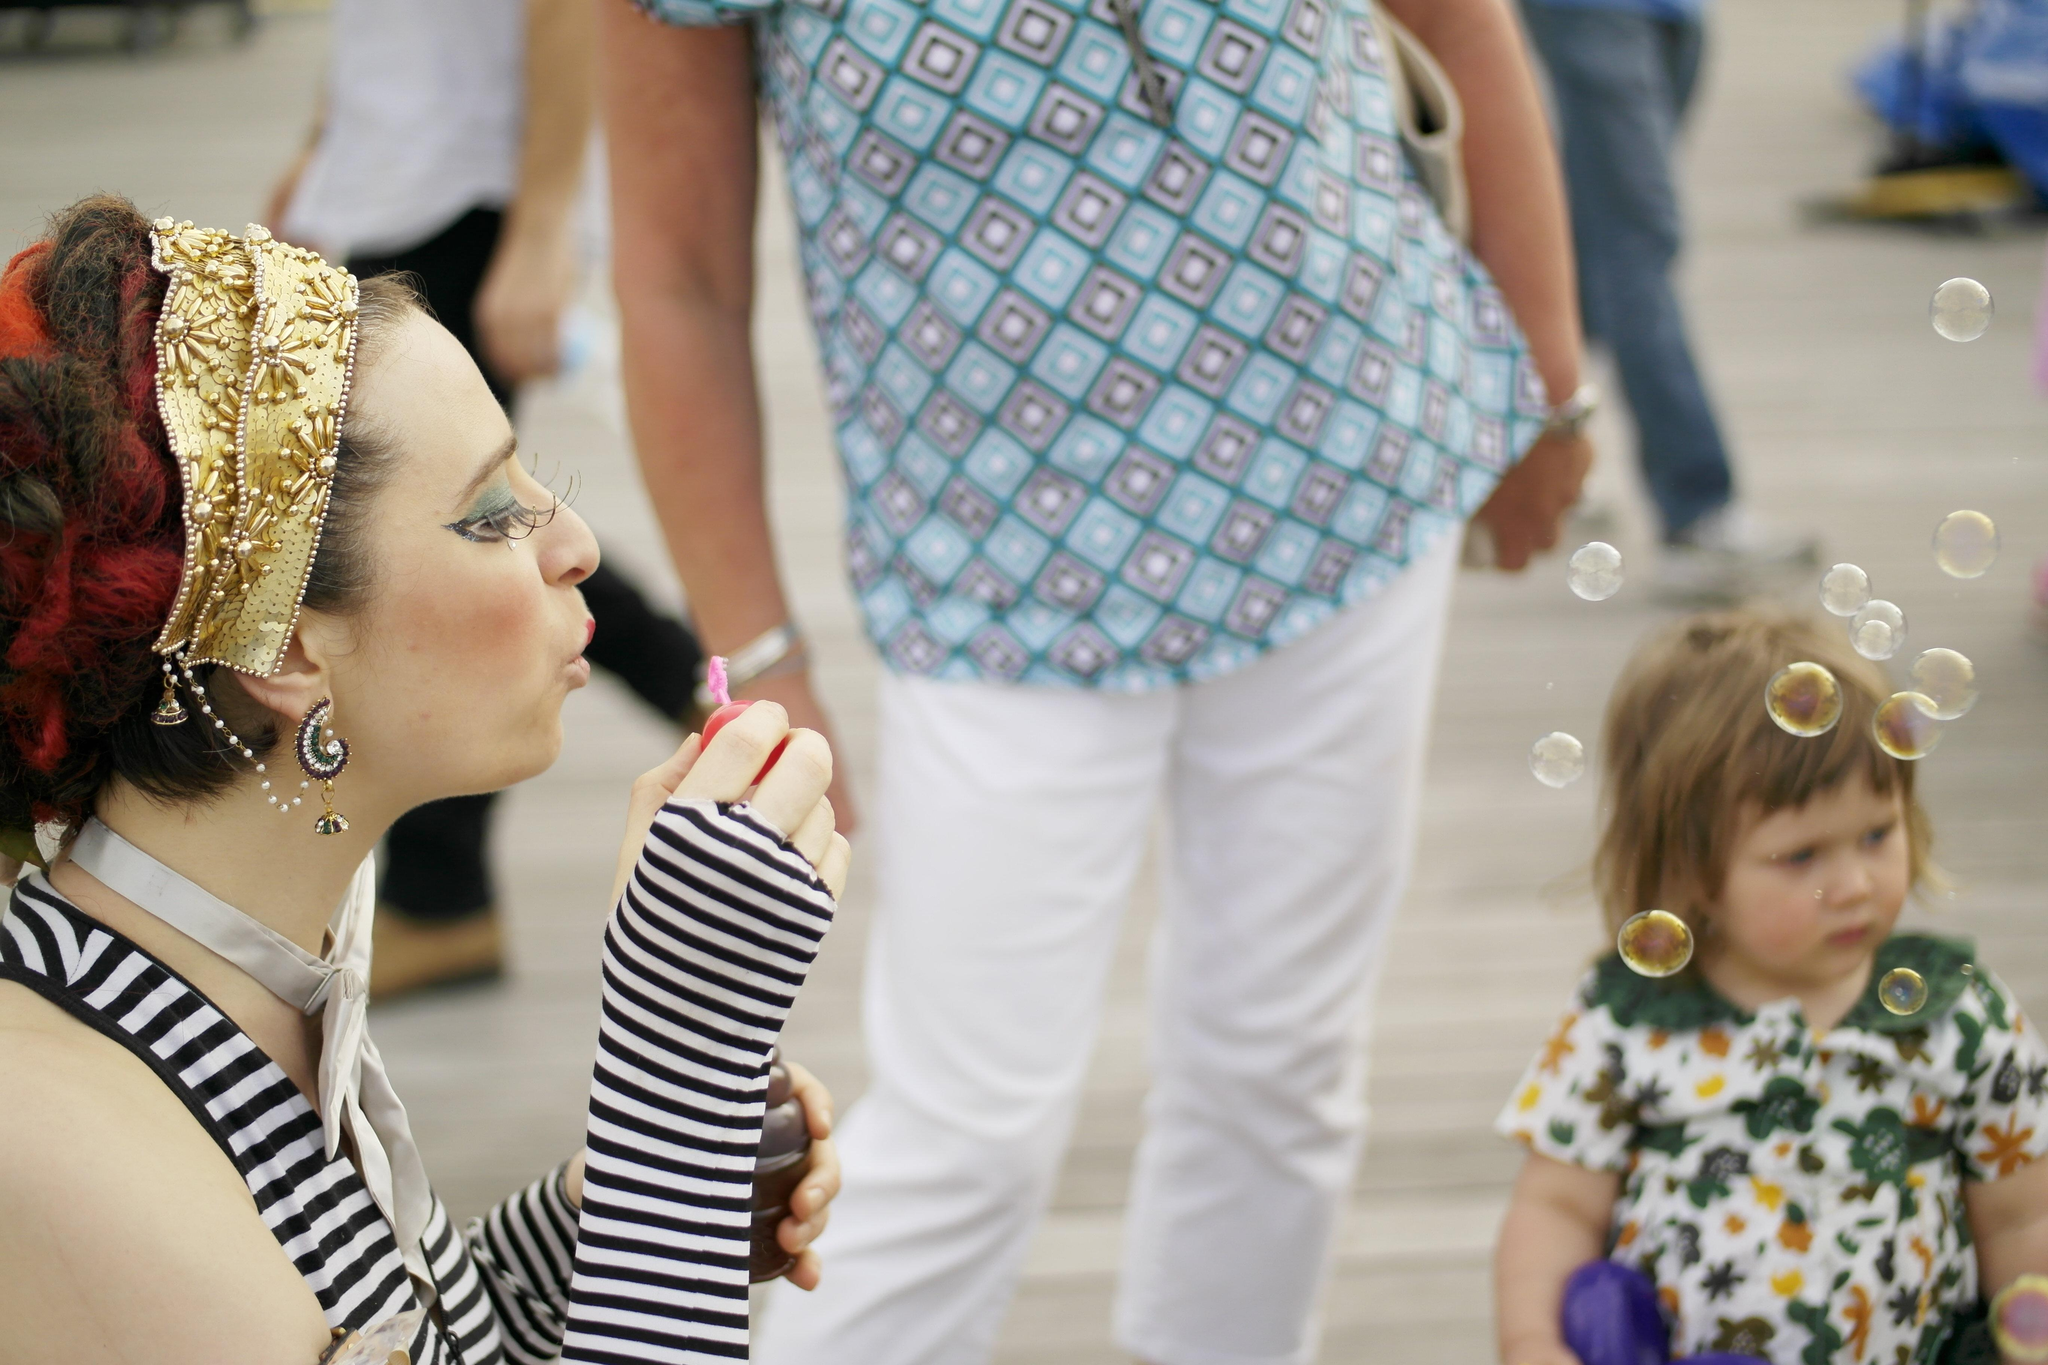How many people are in the image? There is a group of people in the image. What are some of the people in the image doing? Some people are standing, while others are walking. Can you describe the girl's position in the image? The girl is on the right side of the image. What is in front of the girl? Bubbles are present in front of the girl. What type of wine is being served at the mass in the image? There is no mass or wine present in the image; it features a group of people with some standing and walking, a girl on the right side, and bubbles in front of her. 